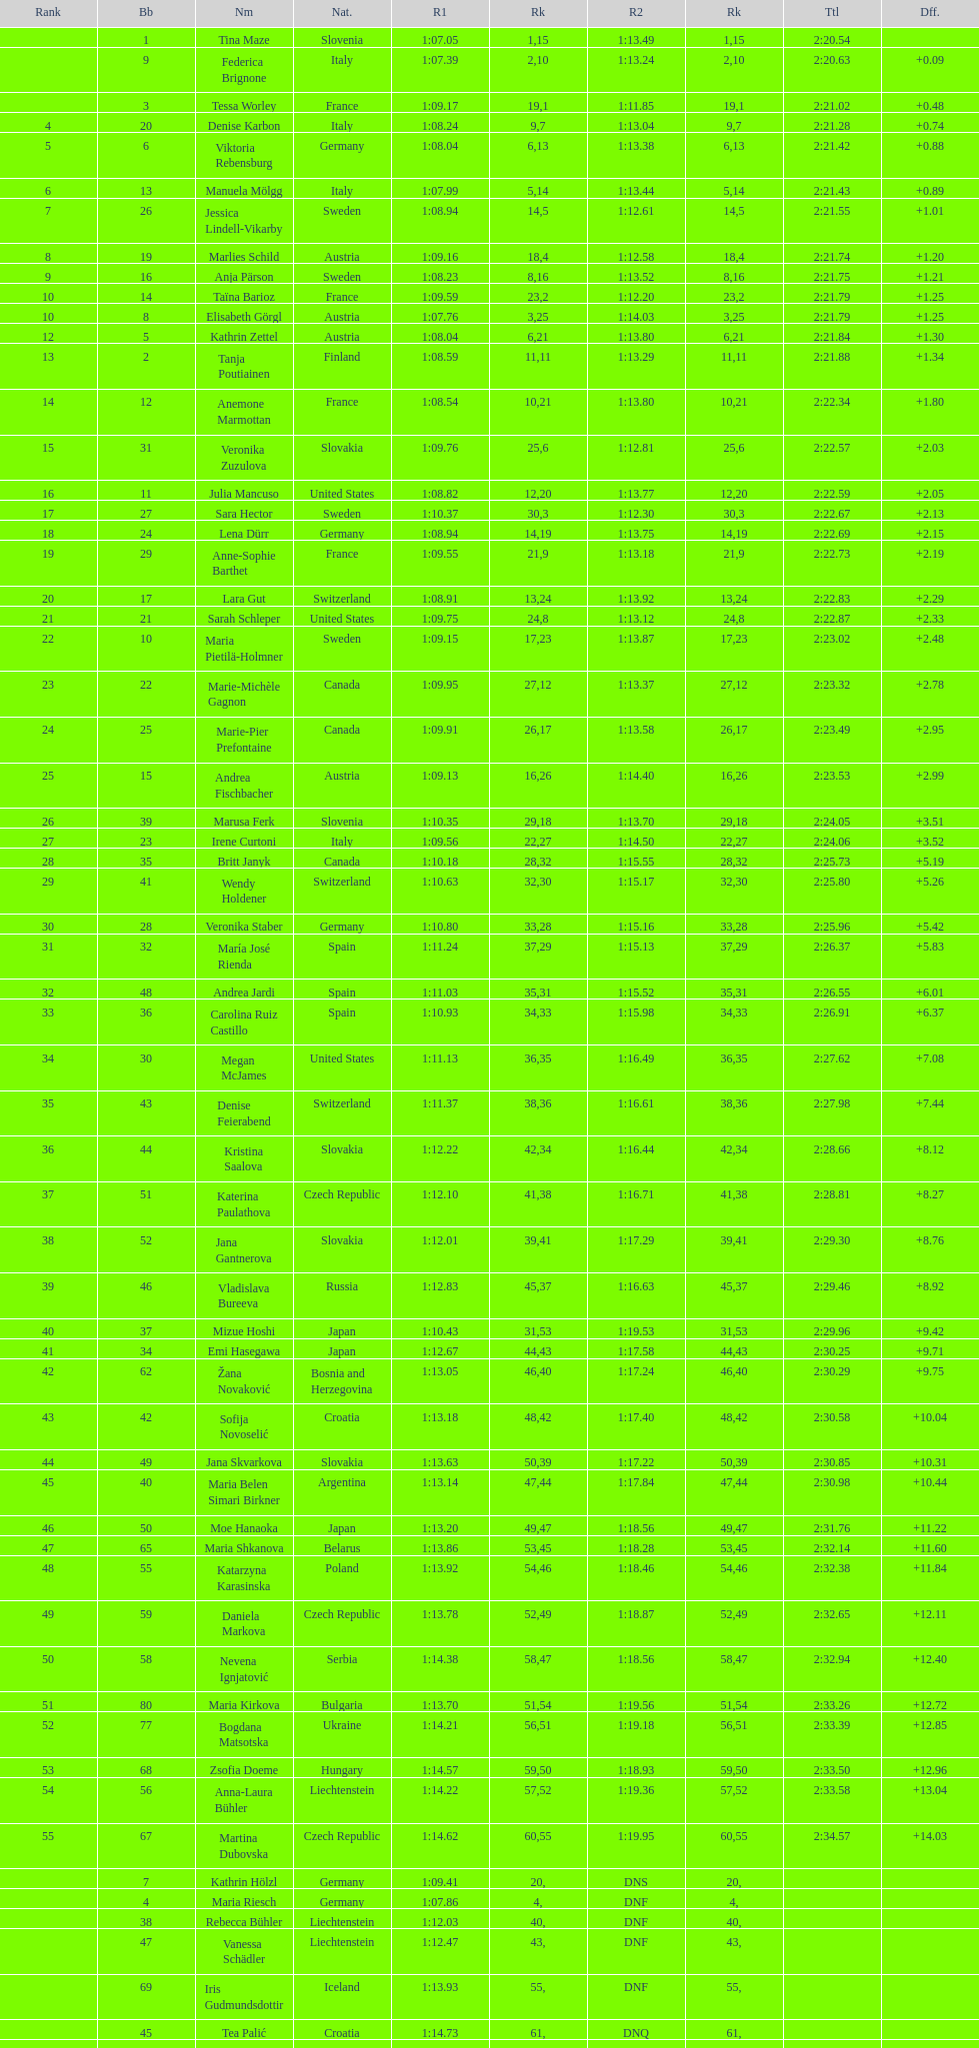How many athletes had the same rank for both run 1 and run 2? 1. 